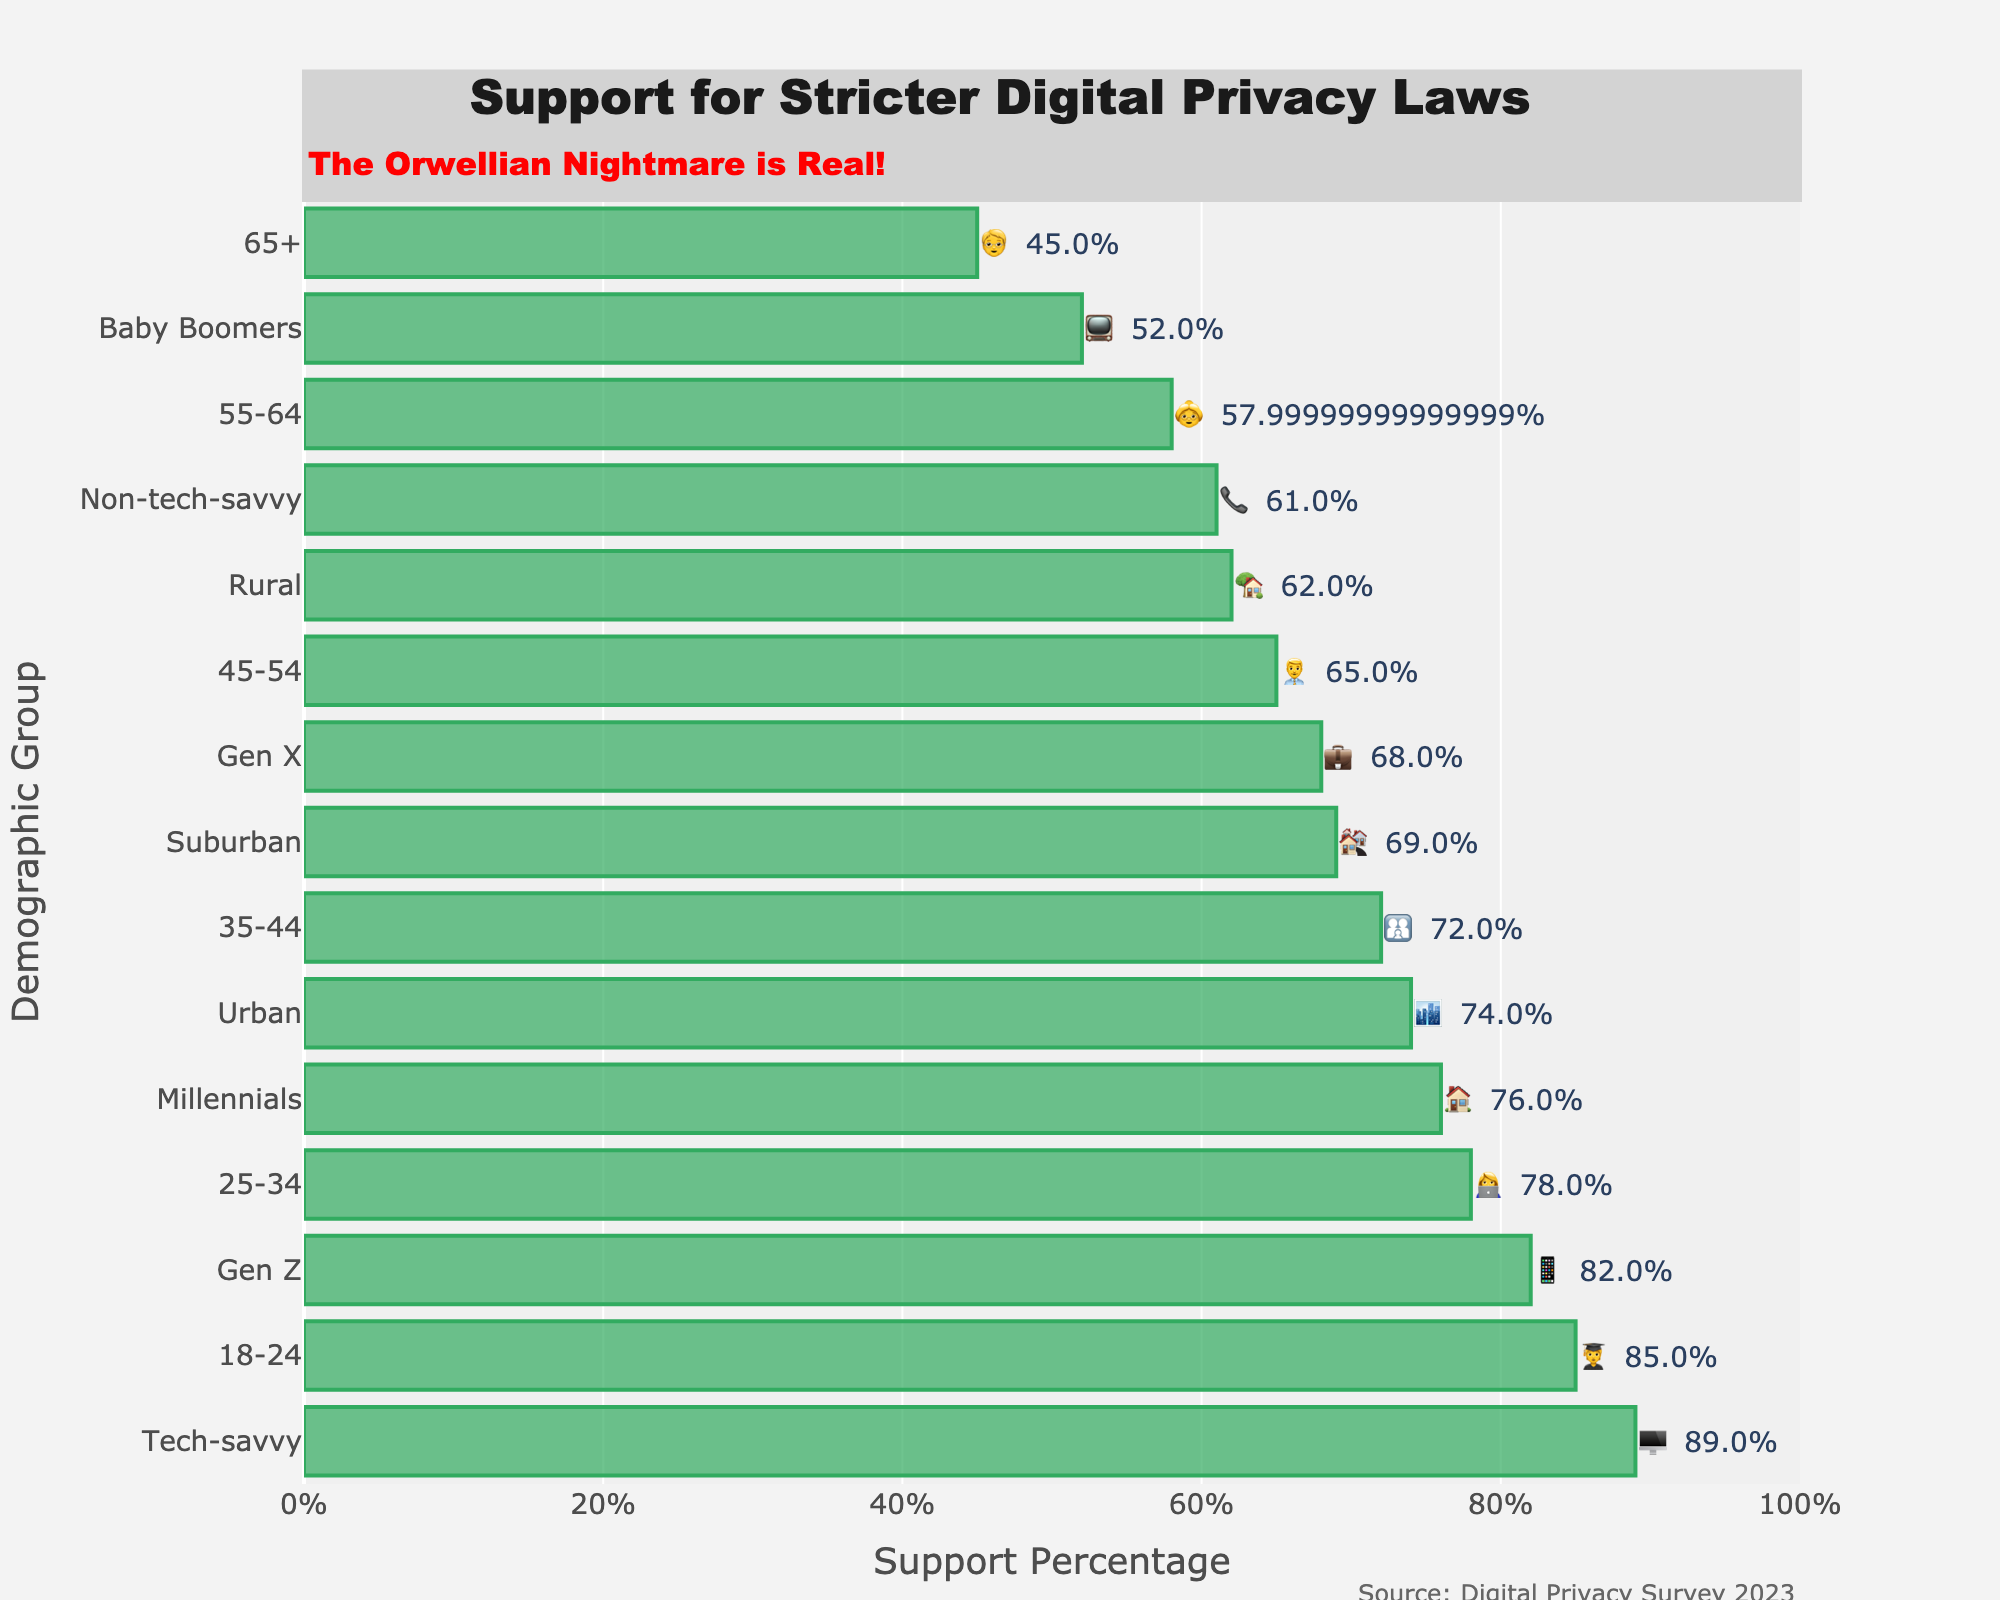What is the title of the figure? The title of the figure is usually prominently displayed at the top of the plot, helping to identify the main topic or subject of the figure. From the data, the title "Support for Stricter Digital Privacy Laws" is given and should be at the top of the figure.
Answer: Support for Stricter Digital Privacy Laws Which age group has the highest support for stricter privacy laws? The figure arranges the groups by support level. From the data, the 18-24 age group (🧑‍🎓) has an 85% support level, which is the highest.
Answer: 18-24 (🧑‍🎓) What is the percentage support for stricter privacy laws among the 55-64 age group? The representative emoji for the 55-64 age group is 👵, and from the data, they show 58% support for stricter privacy laws.
Answer: 58% Compare the support for stricter privacy laws between Gen Z and Baby Boomers. Which group shows greater support? Gen Z (📱) shows 82% support while Baby Boomers (📺) show 52% support. Comparing these percentages, Gen Z has a significantly greater support for stricter privacy laws.
Answer: Gen Z (📱) What is the difference in support for stricter privacy laws between the age group 18-24 and the age group 65+? The support percentages for the age groups 18-24 (🧑‍🎓) and 65+ (🧓) are 85% and 45% respectively. The difference is calculated as 85% - 45% = 40%.
Answer: 40% Which demographic group is represented by the computer emoji (🖥️) and what is their support percentage? The figure should use emojis to indicate demographic groups. The computer emoji (🖥️) represents the Tech-savvy group, and they have an 89% support for stricter privacy laws.
Answer: Tech-savvy (89%) Which living environment group shows the least support for stricter privacy laws? The living environments are Urban (🏙️), Suburban (🏘️), and Rural (🏡). The Rural group shows the least support with 62%.
Answer: Rural (🏡) How many percentage points higher is the support for stricter privacy laws in Urban areas compared to Rural areas? Urban areas (🏙️) show 74% support while Rural areas (🏡) show 62% support. The difference is 74% - 62% = 12 percentage points.
Answer: 12 percentage points What does the annotation "The Orwellian Nightmare is Real!" suggest about the figure? This annotation likely suggests a critical perspective on the need for stricter privacy laws, emphasizing concerns about surveillance and loss of privacy, referencing George Orwell's dystopian themes.
Answer: Concerns about surveillance 